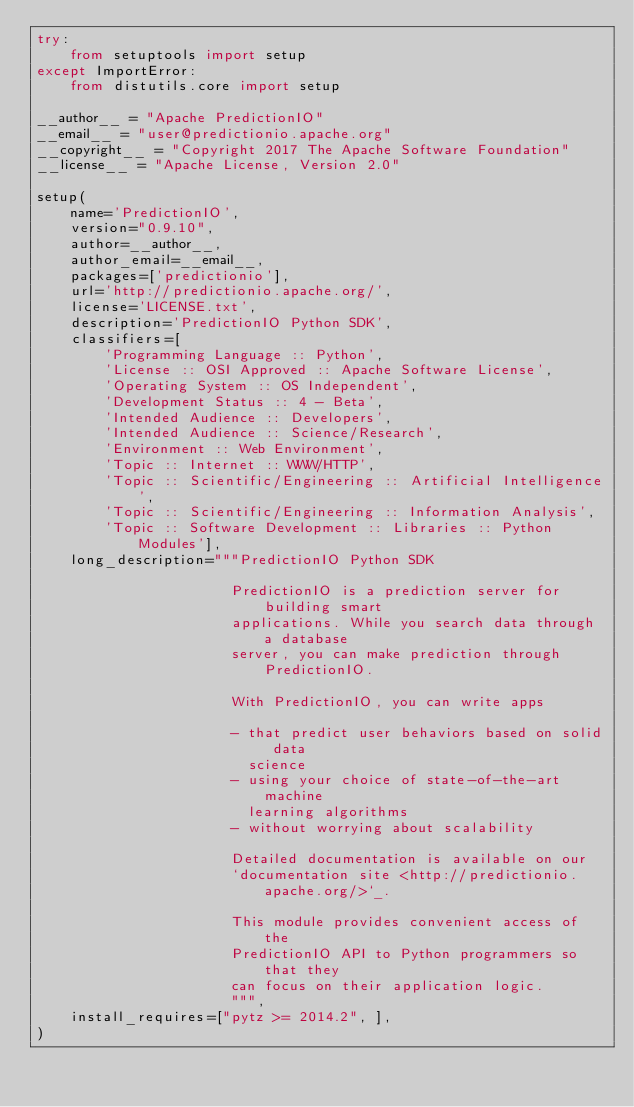Convert code to text. <code><loc_0><loc_0><loc_500><loc_500><_Python_>try:
    from setuptools import setup
except ImportError:
    from distutils.core import setup

__author__ = "Apache PredictionIO"
__email__ = "user@predictionio.apache.org"
__copyright__ = "Copyright 2017 The Apache Software Foundation"
__license__ = "Apache License, Version 2.0"

setup(
    name='PredictionIO',
    version="0.9.10",
    author=__author__,
    author_email=__email__,
    packages=['predictionio'],
    url='http://predictionio.apache.org/',
    license='LICENSE.txt',
    description='PredictionIO Python SDK',
    classifiers=[
        'Programming Language :: Python',
        'License :: OSI Approved :: Apache Software License',
        'Operating System :: OS Independent',
        'Development Status :: 4 - Beta',
        'Intended Audience :: Developers',
        'Intended Audience :: Science/Research',
        'Environment :: Web Environment',
        'Topic :: Internet :: WWW/HTTP',
        'Topic :: Scientific/Engineering :: Artificial Intelligence',
        'Topic :: Scientific/Engineering :: Information Analysis',
        'Topic :: Software Development :: Libraries :: Python Modules'],
    long_description="""PredictionIO Python SDK

                       PredictionIO is a prediction server for building smart
                       applications. While you search data through a database
                       server, you can make prediction through PredictionIO.

                       With PredictionIO, you can write apps

                       - that predict user behaviors based on solid data
                         science
                       - using your choice of state-of-the-art machine
                         learning algorithms
                       - without worrying about scalability

                       Detailed documentation is available on our
                       `documentation site <http://predictionio.apache.org/>`_.

                       This module provides convenient access of the
                       PredictionIO API to Python programmers so that they
                       can focus on their application logic.
                       """,
    install_requires=["pytz >= 2014.2", ],
)
</code> 